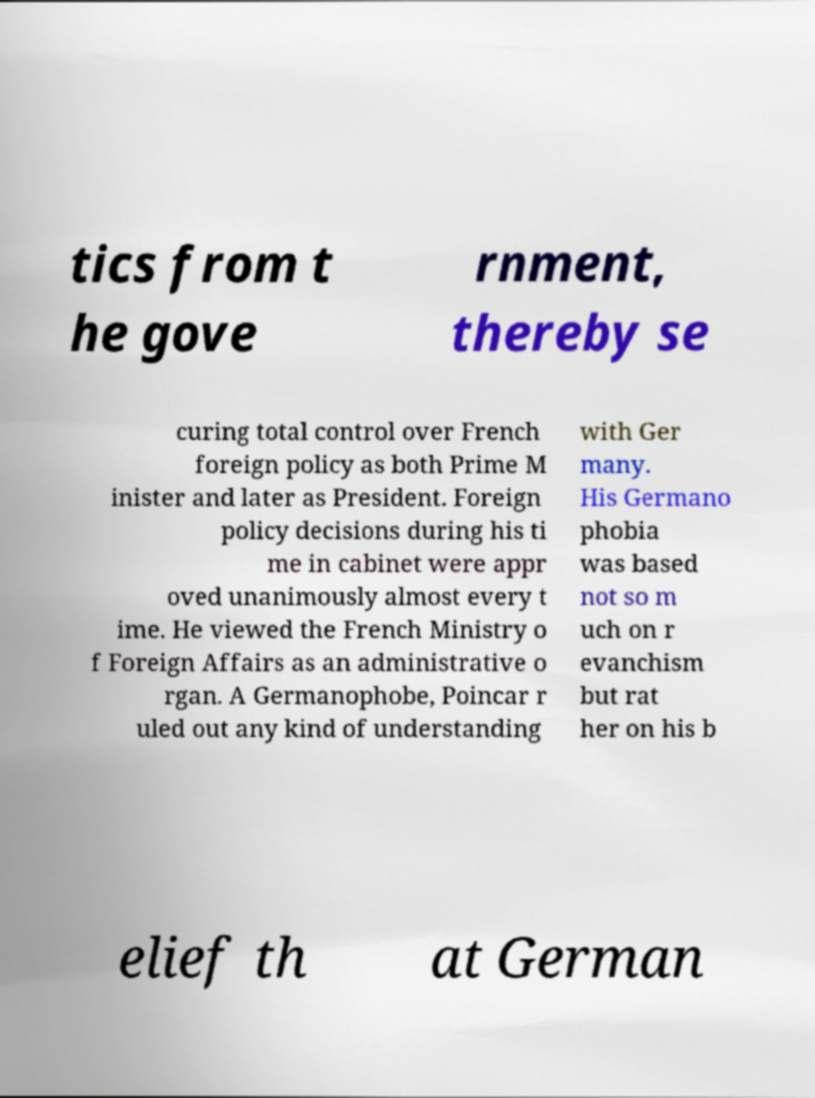For documentation purposes, I need the text within this image transcribed. Could you provide that? tics from t he gove rnment, thereby se curing total control over French foreign policy as both Prime M inister and later as President. Foreign policy decisions during his ti me in cabinet were appr oved unanimously almost every t ime. He viewed the French Ministry o f Foreign Affairs as an administrative o rgan. A Germanophobe, Poincar r uled out any kind of understanding with Ger many. His Germano phobia was based not so m uch on r evanchism but rat her on his b elief th at German 